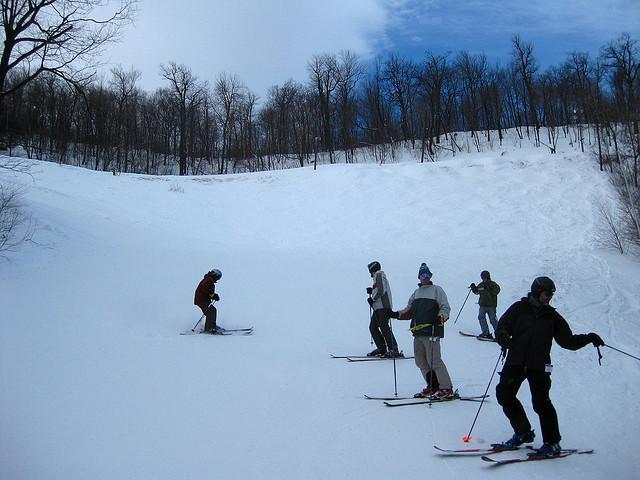How many people?
Give a very brief answer. 5. How many people can be seen?
Give a very brief answer. 2. How many umbrellas are there?
Give a very brief answer. 0. 